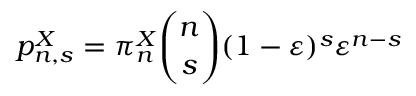<formula> <loc_0><loc_0><loc_500><loc_500>p _ { n , s } ^ { X } = \pi _ { n } ^ { X } \binom { n } { s } ( 1 - \varepsilon ) ^ { s } \varepsilon ^ { n - s }</formula> 